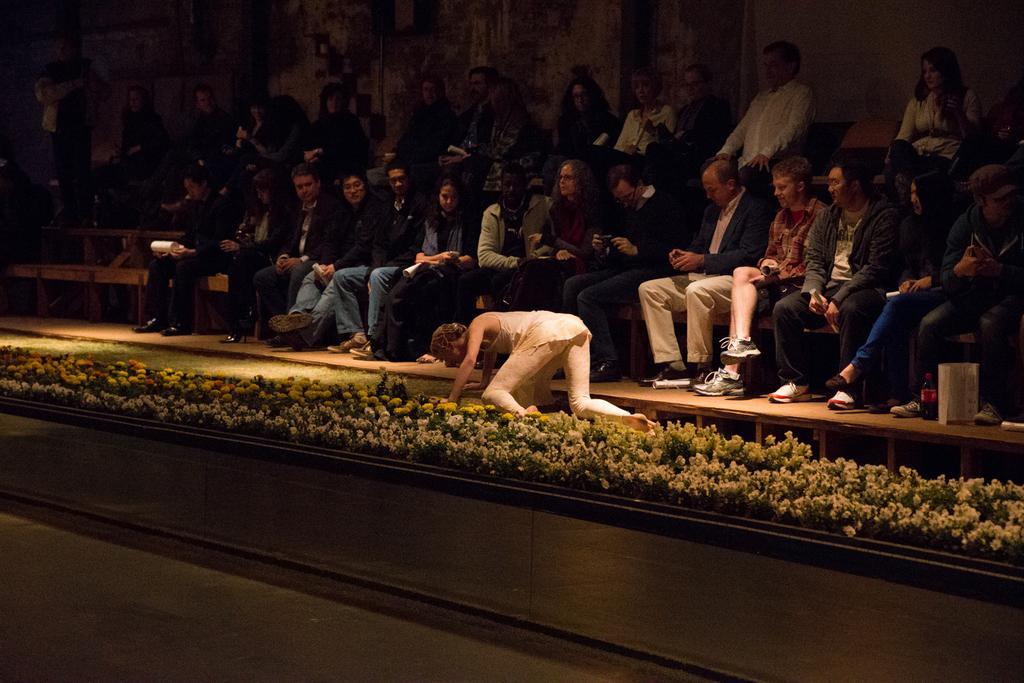Could you give a brief overview of what you see in this image? Here I can see few people are sitting on the chairs. This is looking like a stage. In front of these people I can see a woman on the floor and everyone is looking at her. Beside this woman I can see few flower plants. At the top there is a wall. 